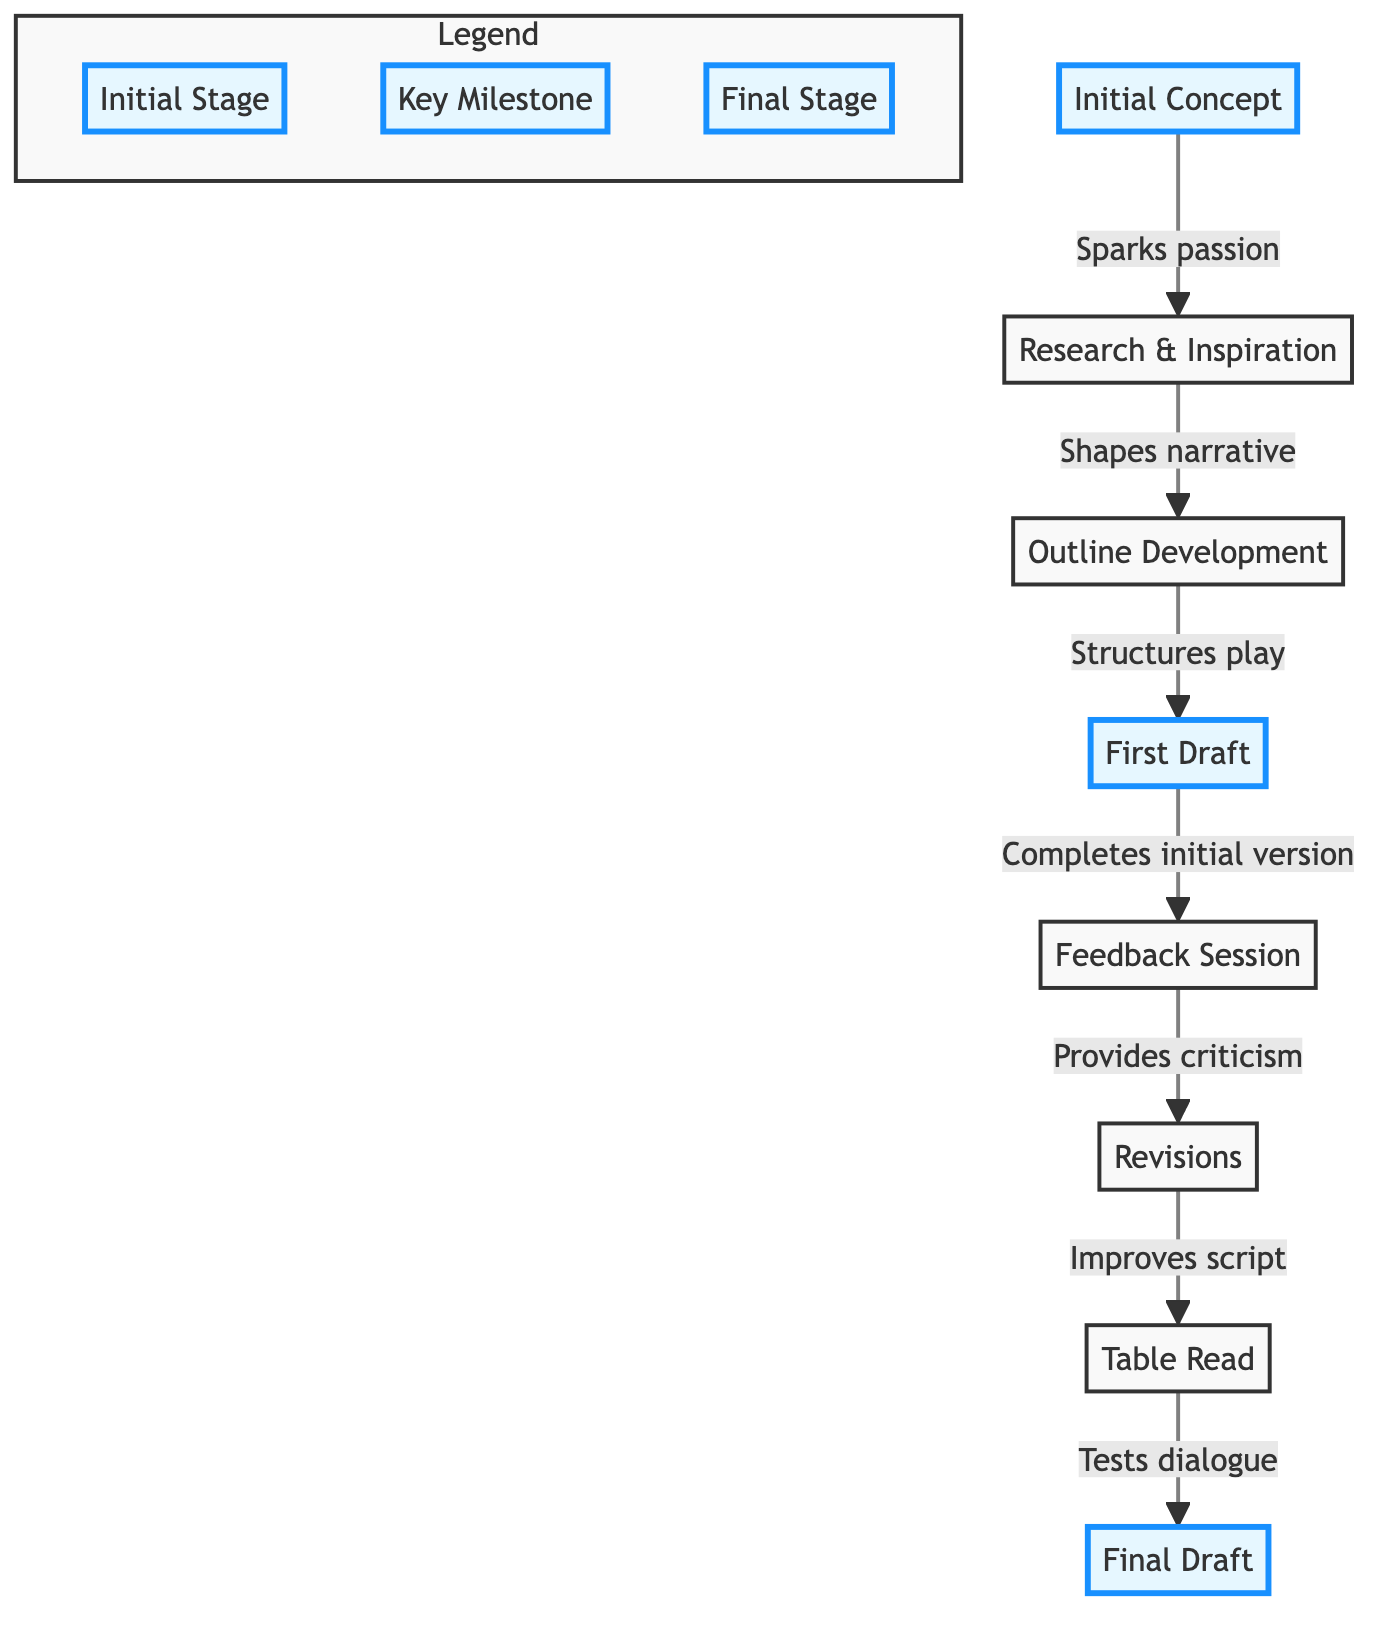What is the first stage of the script development process? The diagram indicates that the first stage is the "Initial Concept." Since the flowchart starts with this element, we can directly identify it.
Answer: Initial Concept How many stages are there in total in this flowchart? By counting all the unique elements listed in the diagram, we find that there are eight stages, each representing a key part of the script development process.
Answer: 8 What does the "Research & Inspiration" stage lead to? The diagram shows a direct arrow connecting "Research & Inspiration" to "Outline Development," indicating that "Research & Inspiration" shapes the narrative, which then leads to outlining.
Answer: Outline Development What happens after "Feedback Session"? According to the flowchart, "Feedback Session" leads to "Revisions." This is depicted by the directed arrow from "Feedback Session" to "Revisions," meaning that feedback prompts script changes.
Answer: Revisions What is the final stage of the script development process? The flowchart lists "Final Draft" at the end of the sequence, signifying that it is the last stage reached after various developments and revisions.
Answer: Final Draft In which stage does the play get tested for dialogue? The flowchart specifies that the "Table Read" stage is when the dialogue is tested with actors, as indicated by the arrow leading to the "Table Read" from "Revisions."
Answer: Table Read What is the relationship between "First Draft" and "Feedback Session"? The "First Draft" connects to "Feedback Session," illustrating that the first draft completion is necessary before getting feedback, highlighting a sequential dependency.
Answer: Provides criticism Which stage emphasizes sharing the script with trusted peers? The flowchart identifies "Feedback Session" as the stage that emphasizes sharing the script with peers for constructive criticism, as described in its connected node.
Answer: Feedback Session What stage comes directly before the "Final Draft"? The diagram shows that "Table Read" is the stage that directly precedes the "Final Draft," indicating that dialogue is evaluated before reaching the final version.
Answer: Table Read 